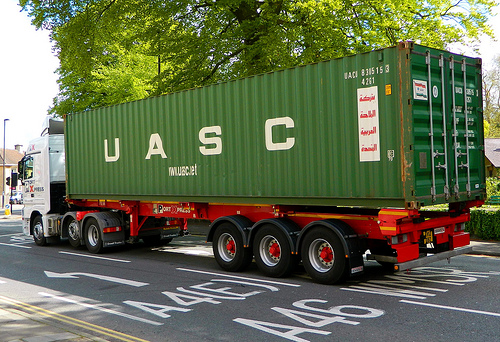How is the item of furniture to the right of the taxi called? The piece of furniture to the right of the taxi is known as a bed. 